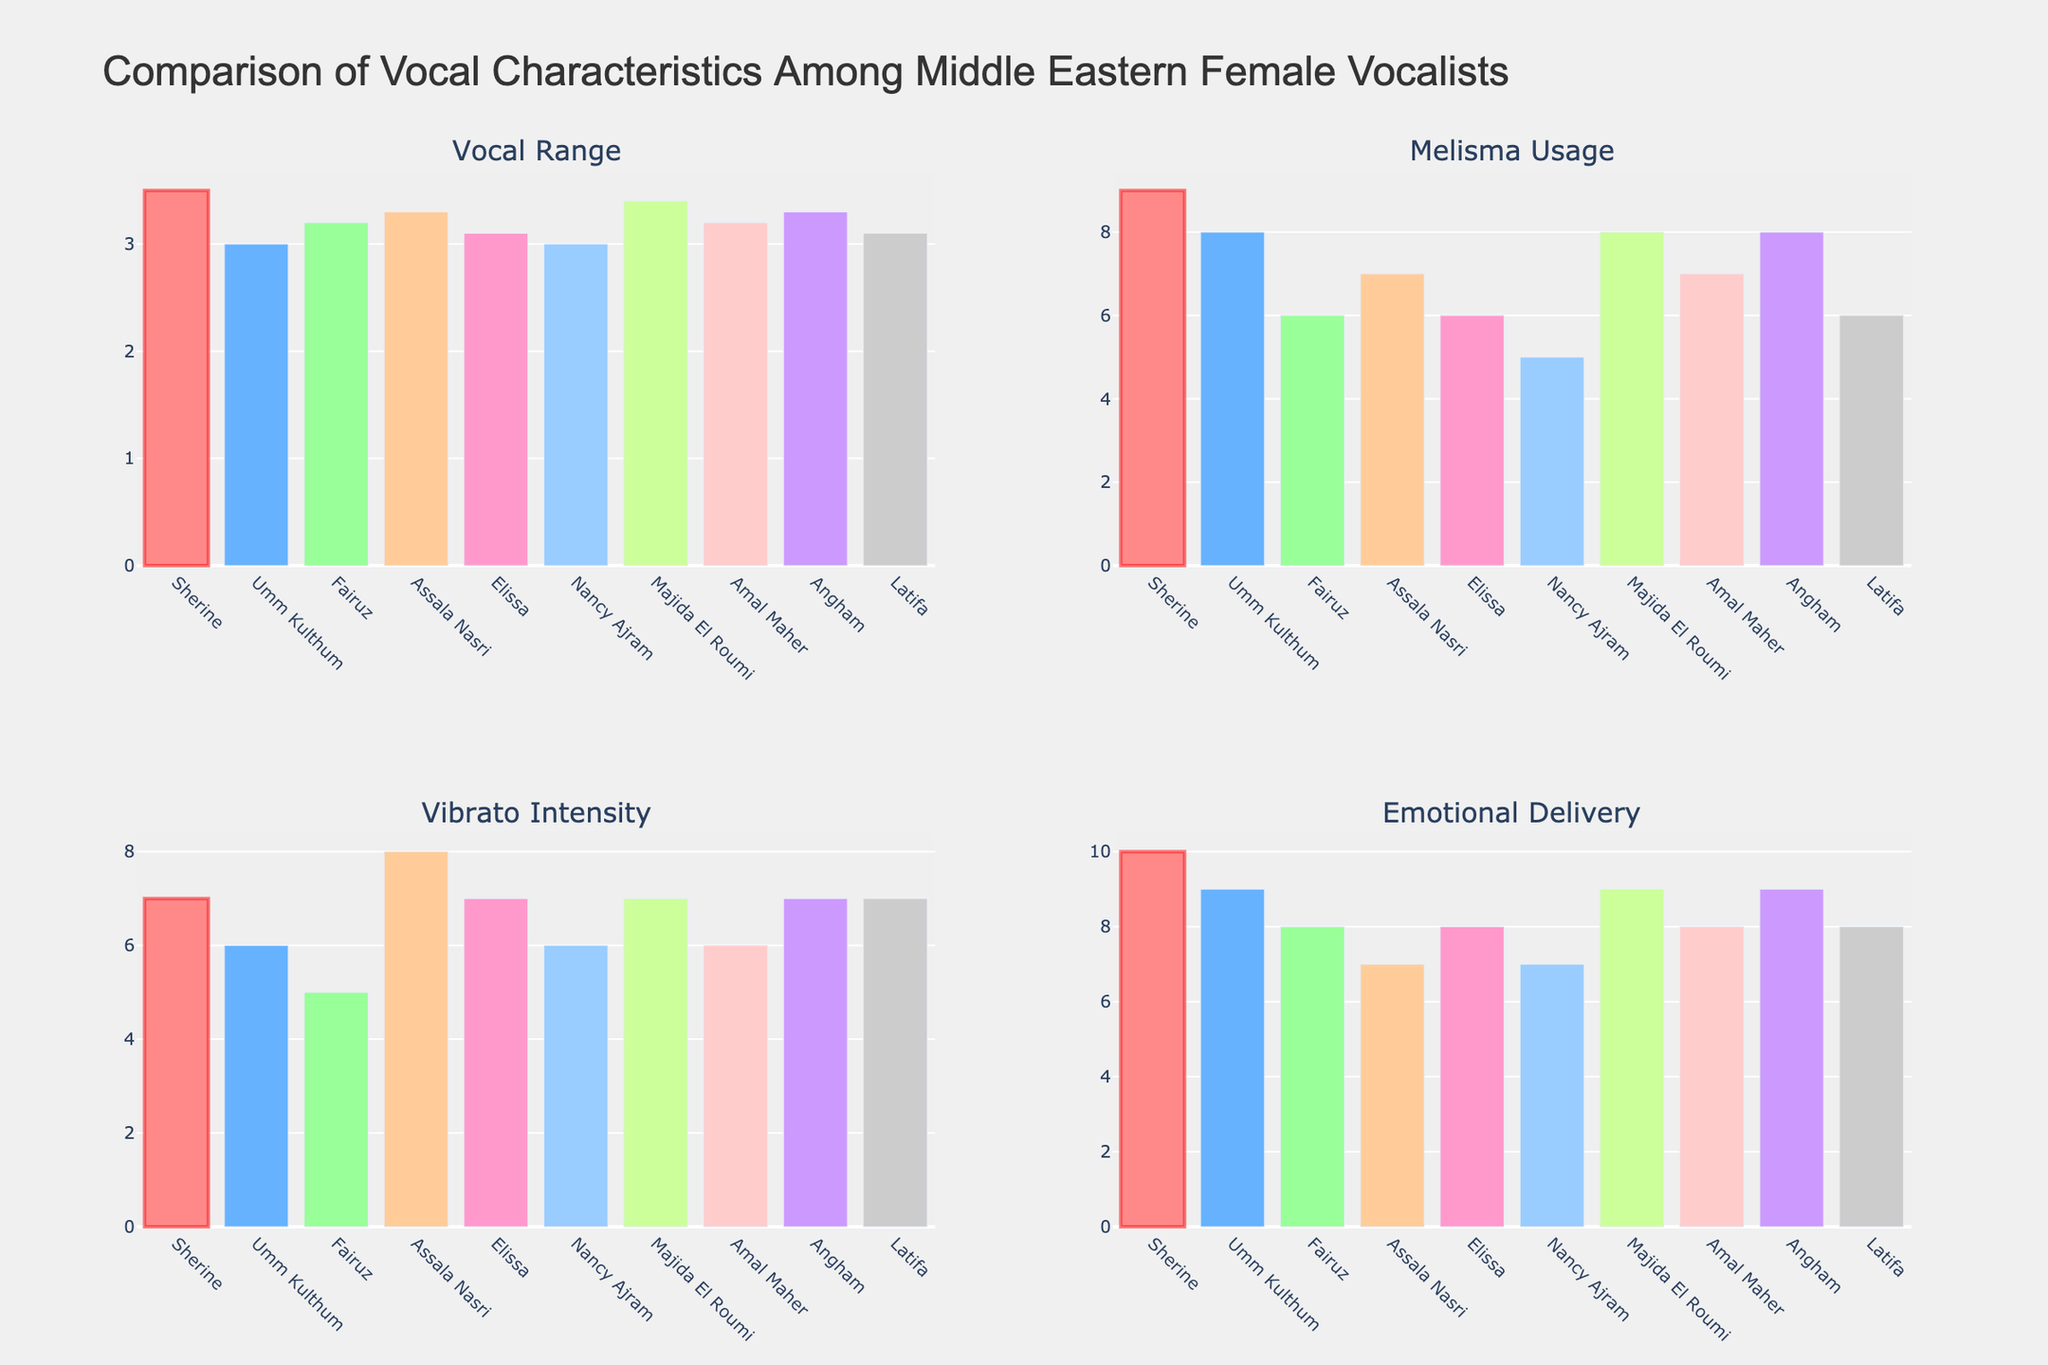What is the total number of firearm sales in 2020 for all weapon types combined? To find the total number of firearm sales in 2020, sum the sales for each type of weapon in that year. The sales are Handguns: 11,320,000, Rifles: 6,680,000, Shotguns: 2,420,000, and Other: 1,140,000. Adding these together gives 11,320,000 + 6,680,000 + 2,420,000 + 1,140,000 = 21,560,000
Answer: 21,560,000 Which weapon type had the highest sales in 2021? Examine the plotted data for 2021 across all four subplots. Handguns, Rifles, Shotguns, and Other each have specific sales numbers. The highest sales number is in the Handguns subplot with a value of 12,660,000
Answer: Handguns By how much did rifle sales increase from 2019 to 2021? To determine the increase, subtract the sales figure for Rifles in 2019 from that in 2021. The sales figures are 4,380,000 in 2019 and 7,450,000 in 2021. Thus, the increase is 7,450,000 - 4,380,000 = 3,070,000
Answer: 3,070,000 What was the general trend for shotgun sales from 2013 to 2022? Observe the Shotguns subplot to understand the trend. The area under the curve starts from 1,440,000 in 2013 and ends at 2,440,000 in 2022, showing an overall upward trend with fluctuations
Answer: Upward trend with fluctuations How did the sales of handguns in 2017 compare to those in 2016? In the Handguns subplot, the bar for 2016 is at 7,664,000, and for 2017, it's at 7,050,000. Comparing these values, 2017 saw a decrease from 2016.
Answer: Decreased Which year experienced the most significant increase in total firearms sales across all types? Compare the total sales of all firearm types year-to-year visually or by summing for each year. The largest increase appears between 2019 (13,590,000) and 2020 (21,560,000), a difference of 7,970,000
Answer: 2020 What is the smallest number of "Other" firearms sold in any year within the period? By examining the "Other" subplot, the smallest value is in 2013 at 560,000
Answer: 560,000 Did rifle sales ever decrease year-on-year between 2013 and 2022? Check the Rifles subplot for year-on-year sales. There is no year where rifle sales decrease, indicating a consistent increase or steadiness
Answer: No Which weapon type shows the most variability in sales over the decade? Compare the subplots visually. Handguns show the widest range from around 5.3 million to 12.66 million, indicating the most variability
Answer: Handguns What was the pattern of firearm sales during the peak year for "Other" types of weapons? In the "Other" subplot, the highest value is in 2021 with 1,280,000. Check other relevant weapon types in that year. Handguns, Rifles, and Shotguns also peak around this year, indicating a general peak
Answer: High across all types in 2021 